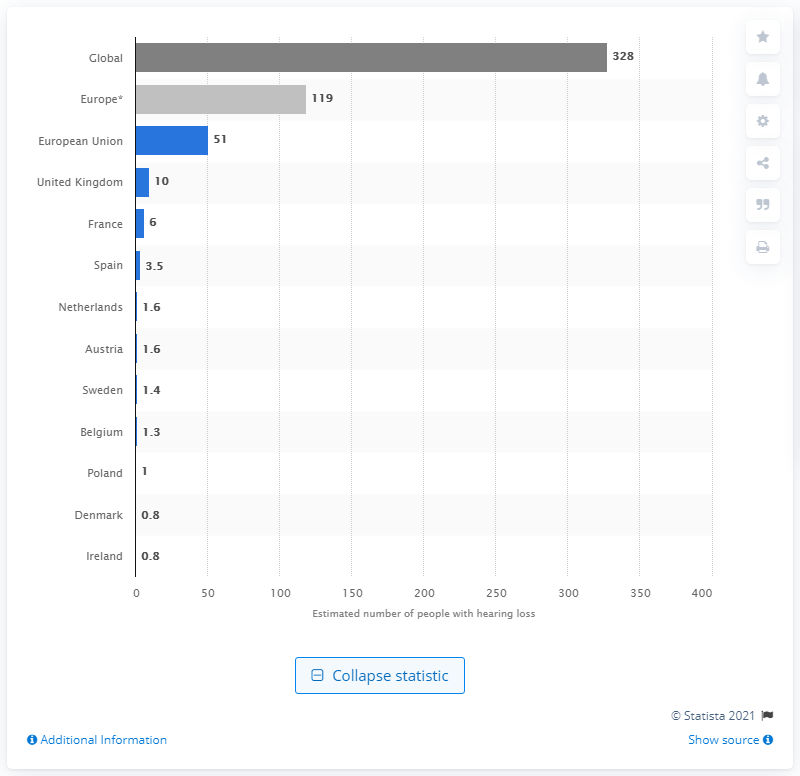Specify some key components in this picture. There are approximately 3.5 million people in Spain who have difficulty hearing. As of 2015, an estimated 119 million people in Europe were hard of hearing. 